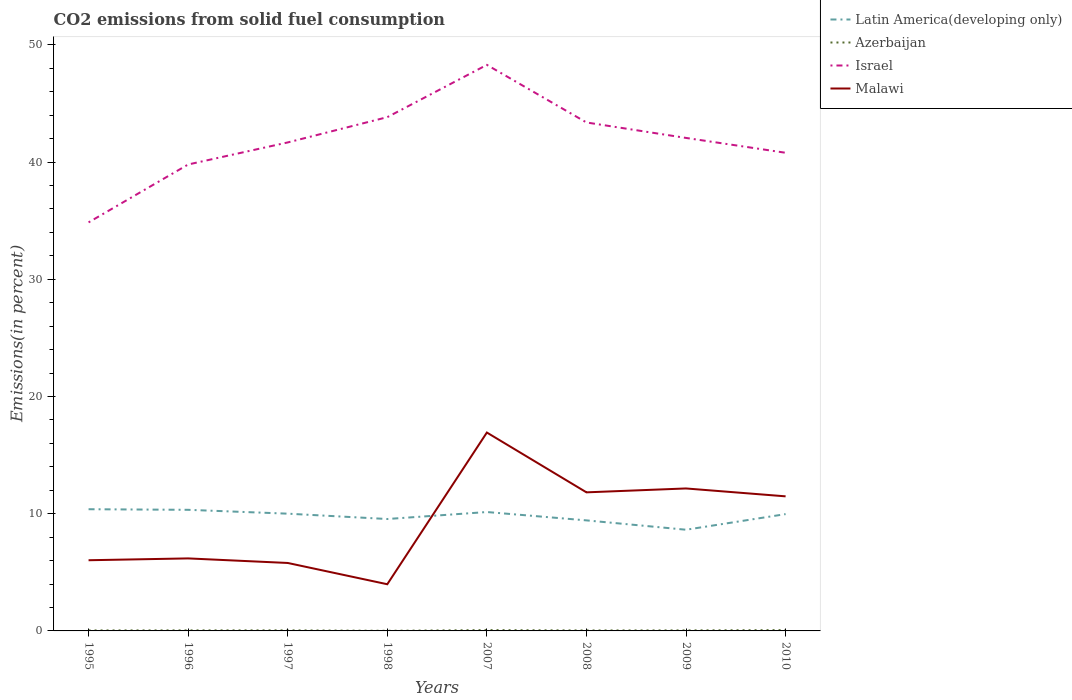Does the line corresponding to Malawi intersect with the line corresponding to Latin America(developing only)?
Your answer should be compact. Yes. Is the number of lines equal to the number of legend labels?
Provide a succinct answer. Yes. Across all years, what is the maximum total CO2 emitted in Latin America(developing only)?
Give a very brief answer. 8.63. What is the total total CO2 emitted in Azerbaijan in the graph?
Ensure brevity in your answer.  -0.03. What is the difference between the highest and the second highest total CO2 emitted in Israel?
Make the answer very short. 13.44. What is the difference between the highest and the lowest total CO2 emitted in Azerbaijan?
Provide a succinct answer. 3. Is the total CO2 emitted in Latin America(developing only) strictly greater than the total CO2 emitted in Azerbaijan over the years?
Give a very brief answer. No. How many lines are there?
Offer a very short reply. 4. Where does the legend appear in the graph?
Your answer should be compact. Top right. How are the legend labels stacked?
Ensure brevity in your answer.  Vertical. What is the title of the graph?
Give a very brief answer. CO2 emissions from solid fuel consumption. What is the label or title of the Y-axis?
Make the answer very short. Emissions(in percent). What is the Emissions(in percent) in Latin America(developing only) in 1995?
Provide a short and direct response. 10.38. What is the Emissions(in percent) of Azerbaijan in 1995?
Ensure brevity in your answer.  0.04. What is the Emissions(in percent) of Israel in 1995?
Your answer should be very brief. 34.85. What is the Emissions(in percent) in Malawi in 1995?
Ensure brevity in your answer.  6.03. What is the Emissions(in percent) of Latin America(developing only) in 1996?
Your answer should be compact. 10.33. What is the Emissions(in percent) of Azerbaijan in 1996?
Provide a succinct answer. 0.05. What is the Emissions(in percent) in Israel in 1996?
Keep it short and to the point. 39.79. What is the Emissions(in percent) of Malawi in 1996?
Ensure brevity in your answer.  6.19. What is the Emissions(in percent) in Latin America(developing only) in 1997?
Give a very brief answer. 10. What is the Emissions(in percent) of Azerbaijan in 1997?
Ensure brevity in your answer.  0.05. What is the Emissions(in percent) in Israel in 1997?
Your answer should be compact. 41.67. What is the Emissions(in percent) of Malawi in 1997?
Give a very brief answer. 5.8. What is the Emissions(in percent) of Latin America(developing only) in 1998?
Provide a short and direct response. 9.55. What is the Emissions(in percent) in Azerbaijan in 1998?
Ensure brevity in your answer.  0.01. What is the Emissions(in percent) of Israel in 1998?
Offer a very short reply. 43.83. What is the Emissions(in percent) of Malawi in 1998?
Give a very brief answer. 3.98. What is the Emissions(in percent) of Latin America(developing only) in 2007?
Your answer should be very brief. 10.14. What is the Emissions(in percent) of Azerbaijan in 2007?
Provide a short and direct response. 0.07. What is the Emissions(in percent) in Israel in 2007?
Provide a short and direct response. 48.29. What is the Emissions(in percent) in Malawi in 2007?
Provide a succinct answer. 16.92. What is the Emissions(in percent) in Latin America(developing only) in 2008?
Keep it short and to the point. 9.43. What is the Emissions(in percent) of Azerbaijan in 2008?
Provide a succinct answer. 0.04. What is the Emissions(in percent) in Israel in 2008?
Offer a very short reply. 43.37. What is the Emissions(in percent) in Malawi in 2008?
Offer a very short reply. 11.82. What is the Emissions(in percent) of Latin America(developing only) in 2009?
Make the answer very short. 8.63. What is the Emissions(in percent) of Azerbaijan in 2009?
Your answer should be compact. 0.05. What is the Emissions(in percent) of Israel in 2009?
Your answer should be very brief. 42.05. What is the Emissions(in percent) of Malawi in 2009?
Your answer should be compact. 12.15. What is the Emissions(in percent) in Latin America(developing only) in 2010?
Offer a very short reply. 9.96. What is the Emissions(in percent) in Azerbaijan in 2010?
Give a very brief answer. 0.07. What is the Emissions(in percent) in Israel in 2010?
Your answer should be compact. 40.79. What is the Emissions(in percent) in Malawi in 2010?
Offer a very short reply. 11.48. Across all years, what is the maximum Emissions(in percent) in Latin America(developing only)?
Offer a terse response. 10.38. Across all years, what is the maximum Emissions(in percent) in Azerbaijan?
Keep it short and to the point. 0.07. Across all years, what is the maximum Emissions(in percent) in Israel?
Ensure brevity in your answer.  48.29. Across all years, what is the maximum Emissions(in percent) in Malawi?
Give a very brief answer. 16.92. Across all years, what is the minimum Emissions(in percent) of Latin America(developing only)?
Provide a short and direct response. 8.63. Across all years, what is the minimum Emissions(in percent) of Azerbaijan?
Give a very brief answer. 0.01. Across all years, what is the minimum Emissions(in percent) of Israel?
Offer a very short reply. 34.85. Across all years, what is the minimum Emissions(in percent) of Malawi?
Your response must be concise. 3.98. What is the total Emissions(in percent) of Latin America(developing only) in the graph?
Make the answer very short. 78.43. What is the total Emissions(in percent) in Azerbaijan in the graph?
Provide a short and direct response. 0.38. What is the total Emissions(in percent) in Israel in the graph?
Provide a succinct answer. 334.64. What is the total Emissions(in percent) of Malawi in the graph?
Give a very brief answer. 74.37. What is the difference between the Emissions(in percent) in Latin America(developing only) in 1995 and that in 1996?
Your answer should be very brief. 0.05. What is the difference between the Emissions(in percent) of Azerbaijan in 1995 and that in 1996?
Your answer should be compact. -0. What is the difference between the Emissions(in percent) in Israel in 1995 and that in 1996?
Provide a succinct answer. -4.94. What is the difference between the Emissions(in percent) in Malawi in 1995 and that in 1996?
Your answer should be very brief. -0.16. What is the difference between the Emissions(in percent) of Latin America(developing only) in 1995 and that in 1997?
Provide a succinct answer. 0.38. What is the difference between the Emissions(in percent) in Azerbaijan in 1995 and that in 1997?
Make the answer very short. -0.01. What is the difference between the Emissions(in percent) of Israel in 1995 and that in 1997?
Your answer should be very brief. -6.82. What is the difference between the Emissions(in percent) in Malawi in 1995 and that in 1997?
Offer a very short reply. 0.23. What is the difference between the Emissions(in percent) in Latin America(developing only) in 1995 and that in 1998?
Offer a very short reply. 0.84. What is the difference between the Emissions(in percent) in Azerbaijan in 1995 and that in 1998?
Offer a terse response. 0.03. What is the difference between the Emissions(in percent) in Israel in 1995 and that in 1998?
Offer a terse response. -8.98. What is the difference between the Emissions(in percent) in Malawi in 1995 and that in 1998?
Provide a short and direct response. 2.05. What is the difference between the Emissions(in percent) in Latin America(developing only) in 1995 and that in 2007?
Your answer should be very brief. 0.24. What is the difference between the Emissions(in percent) in Azerbaijan in 1995 and that in 2007?
Offer a terse response. -0.03. What is the difference between the Emissions(in percent) in Israel in 1995 and that in 2007?
Provide a succinct answer. -13.44. What is the difference between the Emissions(in percent) of Malawi in 1995 and that in 2007?
Provide a short and direct response. -10.89. What is the difference between the Emissions(in percent) in Latin America(developing only) in 1995 and that in 2008?
Ensure brevity in your answer.  0.95. What is the difference between the Emissions(in percent) in Azerbaijan in 1995 and that in 2008?
Offer a very short reply. 0. What is the difference between the Emissions(in percent) in Israel in 1995 and that in 2008?
Your response must be concise. -8.52. What is the difference between the Emissions(in percent) of Malawi in 1995 and that in 2008?
Offer a very short reply. -5.79. What is the difference between the Emissions(in percent) in Latin America(developing only) in 1995 and that in 2009?
Give a very brief answer. 1.75. What is the difference between the Emissions(in percent) in Azerbaijan in 1995 and that in 2009?
Keep it short and to the point. -0. What is the difference between the Emissions(in percent) in Israel in 1995 and that in 2009?
Ensure brevity in your answer.  -7.2. What is the difference between the Emissions(in percent) of Malawi in 1995 and that in 2009?
Your response must be concise. -6.12. What is the difference between the Emissions(in percent) of Latin America(developing only) in 1995 and that in 2010?
Your answer should be compact. 0.42. What is the difference between the Emissions(in percent) in Azerbaijan in 1995 and that in 2010?
Ensure brevity in your answer.  -0.03. What is the difference between the Emissions(in percent) in Israel in 1995 and that in 2010?
Provide a short and direct response. -5.94. What is the difference between the Emissions(in percent) of Malawi in 1995 and that in 2010?
Keep it short and to the point. -5.45. What is the difference between the Emissions(in percent) of Latin America(developing only) in 1996 and that in 1997?
Keep it short and to the point. 0.33. What is the difference between the Emissions(in percent) of Azerbaijan in 1996 and that in 1997?
Make the answer very short. -0. What is the difference between the Emissions(in percent) of Israel in 1996 and that in 1997?
Your answer should be very brief. -1.88. What is the difference between the Emissions(in percent) in Malawi in 1996 and that in 1997?
Ensure brevity in your answer.  0.39. What is the difference between the Emissions(in percent) of Latin America(developing only) in 1996 and that in 1998?
Give a very brief answer. 0.78. What is the difference between the Emissions(in percent) of Azerbaijan in 1996 and that in 1998?
Your answer should be compact. 0.04. What is the difference between the Emissions(in percent) in Israel in 1996 and that in 1998?
Your answer should be compact. -4.04. What is the difference between the Emissions(in percent) of Malawi in 1996 and that in 1998?
Provide a short and direct response. 2.2. What is the difference between the Emissions(in percent) of Latin America(developing only) in 1996 and that in 2007?
Provide a succinct answer. 0.19. What is the difference between the Emissions(in percent) in Azerbaijan in 1996 and that in 2007?
Give a very brief answer. -0.03. What is the difference between the Emissions(in percent) of Israel in 1996 and that in 2007?
Your response must be concise. -8.5. What is the difference between the Emissions(in percent) of Malawi in 1996 and that in 2007?
Provide a short and direct response. -10.74. What is the difference between the Emissions(in percent) of Latin America(developing only) in 1996 and that in 2008?
Your answer should be very brief. 0.9. What is the difference between the Emissions(in percent) of Azerbaijan in 1996 and that in 2008?
Ensure brevity in your answer.  0.01. What is the difference between the Emissions(in percent) in Israel in 1996 and that in 2008?
Make the answer very short. -3.59. What is the difference between the Emissions(in percent) of Malawi in 1996 and that in 2008?
Give a very brief answer. -5.64. What is the difference between the Emissions(in percent) of Latin America(developing only) in 1996 and that in 2009?
Provide a succinct answer. 1.7. What is the difference between the Emissions(in percent) in Azerbaijan in 1996 and that in 2009?
Make the answer very short. 0. What is the difference between the Emissions(in percent) in Israel in 1996 and that in 2009?
Your response must be concise. -2.27. What is the difference between the Emissions(in percent) of Malawi in 1996 and that in 2009?
Your answer should be very brief. -5.97. What is the difference between the Emissions(in percent) in Latin America(developing only) in 1996 and that in 2010?
Keep it short and to the point. 0.37. What is the difference between the Emissions(in percent) of Azerbaijan in 1996 and that in 2010?
Your response must be concise. -0.03. What is the difference between the Emissions(in percent) of Israel in 1996 and that in 2010?
Keep it short and to the point. -1. What is the difference between the Emissions(in percent) of Malawi in 1996 and that in 2010?
Provide a short and direct response. -5.29. What is the difference between the Emissions(in percent) of Latin America(developing only) in 1997 and that in 1998?
Your answer should be very brief. 0.46. What is the difference between the Emissions(in percent) in Azerbaijan in 1997 and that in 1998?
Keep it short and to the point. 0.04. What is the difference between the Emissions(in percent) of Israel in 1997 and that in 1998?
Your response must be concise. -2.16. What is the difference between the Emissions(in percent) in Malawi in 1997 and that in 1998?
Your response must be concise. 1.81. What is the difference between the Emissions(in percent) of Latin America(developing only) in 1997 and that in 2007?
Give a very brief answer. -0.14. What is the difference between the Emissions(in percent) in Azerbaijan in 1997 and that in 2007?
Offer a terse response. -0.02. What is the difference between the Emissions(in percent) in Israel in 1997 and that in 2007?
Your answer should be compact. -6.62. What is the difference between the Emissions(in percent) of Malawi in 1997 and that in 2007?
Make the answer very short. -11.13. What is the difference between the Emissions(in percent) in Latin America(developing only) in 1997 and that in 2008?
Provide a succinct answer. 0.57. What is the difference between the Emissions(in percent) in Azerbaijan in 1997 and that in 2008?
Offer a terse response. 0.01. What is the difference between the Emissions(in percent) of Israel in 1997 and that in 2008?
Ensure brevity in your answer.  -1.7. What is the difference between the Emissions(in percent) of Malawi in 1997 and that in 2008?
Make the answer very short. -6.02. What is the difference between the Emissions(in percent) in Latin America(developing only) in 1997 and that in 2009?
Keep it short and to the point. 1.37. What is the difference between the Emissions(in percent) in Azerbaijan in 1997 and that in 2009?
Give a very brief answer. 0. What is the difference between the Emissions(in percent) in Israel in 1997 and that in 2009?
Ensure brevity in your answer.  -0.38. What is the difference between the Emissions(in percent) in Malawi in 1997 and that in 2009?
Make the answer very short. -6.36. What is the difference between the Emissions(in percent) in Latin America(developing only) in 1997 and that in 2010?
Provide a succinct answer. 0.04. What is the difference between the Emissions(in percent) in Azerbaijan in 1997 and that in 2010?
Provide a succinct answer. -0.02. What is the difference between the Emissions(in percent) of Israel in 1997 and that in 2010?
Ensure brevity in your answer.  0.88. What is the difference between the Emissions(in percent) in Malawi in 1997 and that in 2010?
Offer a very short reply. -5.68. What is the difference between the Emissions(in percent) in Latin America(developing only) in 1998 and that in 2007?
Offer a terse response. -0.6. What is the difference between the Emissions(in percent) of Azerbaijan in 1998 and that in 2007?
Give a very brief answer. -0.06. What is the difference between the Emissions(in percent) in Israel in 1998 and that in 2007?
Your response must be concise. -4.46. What is the difference between the Emissions(in percent) of Malawi in 1998 and that in 2007?
Offer a very short reply. -12.94. What is the difference between the Emissions(in percent) in Latin America(developing only) in 1998 and that in 2008?
Offer a very short reply. 0.12. What is the difference between the Emissions(in percent) in Azerbaijan in 1998 and that in 2008?
Offer a very short reply. -0.03. What is the difference between the Emissions(in percent) of Israel in 1998 and that in 2008?
Ensure brevity in your answer.  0.45. What is the difference between the Emissions(in percent) of Malawi in 1998 and that in 2008?
Give a very brief answer. -7.84. What is the difference between the Emissions(in percent) of Latin America(developing only) in 1998 and that in 2009?
Give a very brief answer. 0.91. What is the difference between the Emissions(in percent) of Azerbaijan in 1998 and that in 2009?
Ensure brevity in your answer.  -0.03. What is the difference between the Emissions(in percent) in Israel in 1998 and that in 2009?
Your answer should be very brief. 1.77. What is the difference between the Emissions(in percent) of Malawi in 1998 and that in 2009?
Provide a short and direct response. -8.17. What is the difference between the Emissions(in percent) of Latin America(developing only) in 1998 and that in 2010?
Your answer should be compact. -0.42. What is the difference between the Emissions(in percent) of Azerbaijan in 1998 and that in 2010?
Make the answer very short. -0.06. What is the difference between the Emissions(in percent) of Israel in 1998 and that in 2010?
Provide a short and direct response. 3.04. What is the difference between the Emissions(in percent) in Malawi in 1998 and that in 2010?
Your answer should be compact. -7.5. What is the difference between the Emissions(in percent) of Latin America(developing only) in 2007 and that in 2008?
Provide a succinct answer. 0.71. What is the difference between the Emissions(in percent) of Azerbaijan in 2007 and that in 2008?
Offer a very short reply. 0.03. What is the difference between the Emissions(in percent) of Israel in 2007 and that in 2008?
Your response must be concise. 4.91. What is the difference between the Emissions(in percent) of Malawi in 2007 and that in 2008?
Your answer should be very brief. 5.1. What is the difference between the Emissions(in percent) of Latin America(developing only) in 2007 and that in 2009?
Provide a succinct answer. 1.51. What is the difference between the Emissions(in percent) of Azerbaijan in 2007 and that in 2009?
Your response must be concise. 0.03. What is the difference between the Emissions(in percent) in Israel in 2007 and that in 2009?
Give a very brief answer. 6.23. What is the difference between the Emissions(in percent) of Malawi in 2007 and that in 2009?
Keep it short and to the point. 4.77. What is the difference between the Emissions(in percent) of Latin America(developing only) in 2007 and that in 2010?
Your answer should be compact. 0.18. What is the difference between the Emissions(in percent) of Israel in 2007 and that in 2010?
Your answer should be compact. 7.5. What is the difference between the Emissions(in percent) of Malawi in 2007 and that in 2010?
Keep it short and to the point. 5.44. What is the difference between the Emissions(in percent) in Latin America(developing only) in 2008 and that in 2009?
Keep it short and to the point. 0.8. What is the difference between the Emissions(in percent) of Azerbaijan in 2008 and that in 2009?
Your response must be concise. -0. What is the difference between the Emissions(in percent) in Israel in 2008 and that in 2009?
Keep it short and to the point. 1.32. What is the difference between the Emissions(in percent) of Malawi in 2008 and that in 2009?
Make the answer very short. -0.33. What is the difference between the Emissions(in percent) of Latin America(developing only) in 2008 and that in 2010?
Keep it short and to the point. -0.53. What is the difference between the Emissions(in percent) of Azerbaijan in 2008 and that in 2010?
Offer a terse response. -0.03. What is the difference between the Emissions(in percent) in Israel in 2008 and that in 2010?
Your answer should be very brief. 2.59. What is the difference between the Emissions(in percent) in Malawi in 2008 and that in 2010?
Make the answer very short. 0.34. What is the difference between the Emissions(in percent) in Latin America(developing only) in 2009 and that in 2010?
Ensure brevity in your answer.  -1.33. What is the difference between the Emissions(in percent) of Azerbaijan in 2009 and that in 2010?
Your answer should be very brief. -0.03. What is the difference between the Emissions(in percent) in Israel in 2009 and that in 2010?
Provide a succinct answer. 1.27. What is the difference between the Emissions(in percent) of Malawi in 2009 and that in 2010?
Offer a terse response. 0.67. What is the difference between the Emissions(in percent) in Latin America(developing only) in 1995 and the Emissions(in percent) in Azerbaijan in 1996?
Ensure brevity in your answer.  10.33. What is the difference between the Emissions(in percent) of Latin America(developing only) in 1995 and the Emissions(in percent) of Israel in 1996?
Offer a terse response. -29.41. What is the difference between the Emissions(in percent) in Latin America(developing only) in 1995 and the Emissions(in percent) in Malawi in 1996?
Offer a very short reply. 4.2. What is the difference between the Emissions(in percent) in Azerbaijan in 1995 and the Emissions(in percent) in Israel in 1996?
Provide a short and direct response. -39.74. What is the difference between the Emissions(in percent) in Azerbaijan in 1995 and the Emissions(in percent) in Malawi in 1996?
Offer a terse response. -6.14. What is the difference between the Emissions(in percent) in Israel in 1995 and the Emissions(in percent) in Malawi in 1996?
Give a very brief answer. 28.67. What is the difference between the Emissions(in percent) in Latin America(developing only) in 1995 and the Emissions(in percent) in Azerbaijan in 1997?
Your response must be concise. 10.33. What is the difference between the Emissions(in percent) in Latin America(developing only) in 1995 and the Emissions(in percent) in Israel in 1997?
Your response must be concise. -31.29. What is the difference between the Emissions(in percent) in Latin America(developing only) in 1995 and the Emissions(in percent) in Malawi in 1997?
Provide a short and direct response. 4.58. What is the difference between the Emissions(in percent) in Azerbaijan in 1995 and the Emissions(in percent) in Israel in 1997?
Your answer should be compact. -41.63. What is the difference between the Emissions(in percent) in Azerbaijan in 1995 and the Emissions(in percent) in Malawi in 1997?
Keep it short and to the point. -5.75. What is the difference between the Emissions(in percent) in Israel in 1995 and the Emissions(in percent) in Malawi in 1997?
Ensure brevity in your answer.  29.05. What is the difference between the Emissions(in percent) of Latin America(developing only) in 1995 and the Emissions(in percent) of Azerbaijan in 1998?
Keep it short and to the point. 10.37. What is the difference between the Emissions(in percent) in Latin America(developing only) in 1995 and the Emissions(in percent) in Israel in 1998?
Make the answer very short. -33.45. What is the difference between the Emissions(in percent) in Latin America(developing only) in 1995 and the Emissions(in percent) in Malawi in 1998?
Provide a succinct answer. 6.4. What is the difference between the Emissions(in percent) in Azerbaijan in 1995 and the Emissions(in percent) in Israel in 1998?
Provide a succinct answer. -43.78. What is the difference between the Emissions(in percent) in Azerbaijan in 1995 and the Emissions(in percent) in Malawi in 1998?
Make the answer very short. -3.94. What is the difference between the Emissions(in percent) of Israel in 1995 and the Emissions(in percent) of Malawi in 1998?
Provide a succinct answer. 30.87. What is the difference between the Emissions(in percent) in Latin America(developing only) in 1995 and the Emissions(in percent) in Azerbaijan in 2007?
Make the answer very short. 10.31. What is the difference between the Emissions(in percent) of Latin America(developing only) in 1995 and the Emissions(in percent) of Israel in 2007?
Make the answer very short. -37.91. What is the difference between the Emissions(in percent) in Latin America(developing only) in 1995 and the Emissions(in percent) in Malawi in 2007?
Keep it short and to the point. -6.54. What is the difference between the Emissions(in percent) in Azerbaijan in 1995 and the Emissions(in percent) in Israel in 2007?
Provide a succinct answer. -48.24. What is the difference between the Emissions(in percent) in Azerbaijan in 1995 and the Emissions(in percent) in Malawi in 2007?
Give a very brief answer. -16.88. What is the difference between the Emissions(in percent) of Israel in 1995 and the Emissions(in percent) of Malawi in 2007?
Keep it short and to the point. 17.93. What is the difference between the Emissions(in percent) of Latin America(developing only) in 1995 and the Emissions(in percent) of Azerbaijan in 2008?
Make the answer very short. 10.34. What is the difference between the Emissions(in percent) in Latin America(developing only) in 1995 and the Emissions(in percent) in Israel in 2008?
Give a very brief answer. -32.99. What is the difference between the Emissions(in percent) in Latin America(developing only) in 1995 and the Emissions(in percent) in Malawi in 2008?
Your response must be concise. -1.44. What is the difference between the Emissions(in percent) in Azerbaijan in 1995 and the Emissions(in percent) in Israel in 2008?
Offer a terse response. -43.33. What is the difference between the Emissions(in percent) in Azerbaijan in 1995 and the Emissions(in percent) in Malawi in 2008?
Ensure brevity in your answer.  -11.78. What is the difference between the Emissions(in percent) of Israel in 1995 and the Emissions(in percent) of Malawi in 2008?
Your response must be concise. 23.03. What is the difference between the Emissions(in percent) of Latin America(developing only) in 1995 and the Emissions(in percent) of Azerbaijan in 2009?
Provide a short and direct response. 10.34. What is the difference between the Emissions(in percent) in Latin America(developing only) in 1995 and the Emissions(in percent) in Israel in 2009?
Your answer should be very brief. -31.67. What is the difference between the Emissions(in percent) of Latin America(developing only) in 1995 and the Emissions(in percent) of Malawi in 2009?
Offer a very short reply. -1.77. What is the difference between the Emissions(in percent) in Azerbaijan in 1995 and the Emissions(in percent) in Israel in 2009?
Provide a short and direct response. -42.01. What is the difference between the Emissions(in percent) of Azerbaijan in 1995 and the Emissions(in percent) of Malawi in 2009?
Your answer should be very brief. -12.11. What is the difference between the Emissions(in percent) in Israel in 1995 and the Emissions(in percent) in Malawi in 2009?
Your answer should be compact. 22.7. What is the difference between the Emissions(in percent) in Latin America(developing only) in 1995 and the Emissions(in percent) in Azerbaijan in 2010?
Provide a succinct answer. 10.31. What is the difference between the Emissions(in percent) in Latin America(developing only) in 1995 and the Emissions(in percent) in Israel in 2010?
Provide a succinct answer. -30.41. What is the difference between the Emissions(in percent) in Latin America(developing only) in 1995 and the Emissions(in percent) in Malawi in 2010?
Ensure brevity in your answer.  -1.1. What is the difference between the Emissions(in percent) in Azerbaijan in 1995 and the Emissions(in percent) in Israel in 2010?
Offer a terse response. -40.74. What is the difference between the Emissions(in percent) in Azerbaijan in 1995 and the Emissions(in percent) in Malawi in 2010?
Make the answer very short. -11.44. What is the difference between the Emissions(in percent) in Israel in 1995 and the Emissions(in percent) in Malawi in 2010?
Your response must be concise. 23.37. What is the difference between the Emissions(in percent) in Latin America(developing only) in 1996 and the Emissions(in percent) in Azerbaijan in 1997?
Offer a terse response. 10.28. What is the difference between the Emissions(in percent) of Latin America(developing only) in 1996 and the Emissions(in percent) of Israel in 1997?
Make the answer very short. -31.34. What is the difference between the Emissions(in percent) of Latin America(developing only) in 1996 and the Emissions(in percent) of Malawi in 1997?
Your answer should be compact. 4.53. What is the difference between the Emissions(in percent) in Azerbaijan in 1996 and the Emissions(in percent) in Israel in 1997?
Offer a very short reply. -41.62. What is the difference between the Emissions(in percent) in Azerbaijan in 1996 and the Emissions(in percent) in Malawi in 1997?
Your answer should be compact. -5.75. What is the difference between the Emissions(in percent) in Israel in 1996 and the Emissions(in percent) in Malawi in 1997?
Your answer should be very brief. 33.99. What is the difference between the Emissions(in percent) in Latin America(developing only) in 1996 and the Emissions(in percent) in Azerbaijan in 1998?
Ensure brevity in your answer.  10.32. What is the difference between the Emissions(in percent) in Latin America(developing only) in 1996 and the Emissions(in percent) in Israel in 1998?
Give a very brief answer. -33.5. What is the difference between the Emissions(in percent) in Latin America(developing only) in 1996 and the Emissions(in percent) in Malawi in 1998?
Provide a short and direct response. 6.35. What is the difference between the Emissions(in percent) of Azerbaijan in 1996 and the Emissions(in percent) of Israel in 1998?
Offer a terse response. -43.78. What is the difference between the Emissions(in percent) in Azerbaijan in 1996 and the Emissions(in percent) in Malawi in 1998?
Offer a terse response. -3.94. What is the difference between the Emissions(in percent) in Israel in 1996 and the Emissions(in percent) in Malawi in 1998?
Give a very brief answer. 35.81. What is the difference between the Emissions(in percent) of Latin America(developing only) in 1996 and the Emissions(in percent) of Azerbaijan in 2007?
Your answer should be compact. 10.26. What is the difference between the Emissions(in percent) of Latin America(developing only) in 1996 and the Emissions(in percent) of Israel in 2007?
Your answer should be compact. -37.96. What is the difference between the Emissions(in percent) of Latin America(developing only) in 1996 and the Emissions(in percent) of Malawi in 2007?
Your answer should be compact. -6.59. What is the difference between the Emissions(in percent) of Azerbaijan in 1996 and the Emissions(in percent) of Israel in 2007?
Give a very brief answer. -48.24. What is the difference between the Emissions(in percent) of Azerbaijan in 1996 and the Emissions(in percent) of Malawi in 2007?
Offer a terse response. -16.88. What is the difference between the Emissions(in percent) in Israel in 1996 and the Emissions(in percent) in Malawi in 2007?
Make the answer very short. 22.87. What is the difference between the Emissions(in percent) of Latin America(developing only) in 1996 and the Emissions(in percent) of Azerbaijan in 2008?
Your answer should be compact. 10.29. What is the difference between the Emissions(in percent) of Latin America(developing only) in 1996 and the Emissions(in percent) of Israel in 2008?
Keep it short and to the point. -33.04. What is the difference between the Emissions(in percent) of Latin America(developing only) in 1996 and the Emissions(in percent) of Malawi in 2008?
Your answer should be very brief. -1.49. What is the difference between the Emissions(in percent) in Azerbaijan in 1996 and the Emissions(in percent) in Israel in 2008?
Make the answer very short. -43.33. What is the difference between the Emissions(in percent) of Azerbaijan in 1996 and the Emissions(in percent) of Malawi in 2008?
Provide a short and direct response. -11.77. What is the difference between the Emissions(in percent) in Israel in 1996 and the Emissions(in percent) in Malawi in 2008?
Provide a succinct answer. 27.97. What is the difference between the Emissions(in percent) of Latin America(developing only) in 1996 and the Emissions(in percent) of Azerbaijan in 2009?
Your response must be concise. 10.29. What is the difference between the Emissions(in percent) of Latin America(developing only) in 1996 and the Emissions(in percent) of Israel in 2009?
Offer a terse response. -31.72. What is the difference between the Emissions(in percent) in Latin America(developing only) in 1996 and the Emissions(in percent) in Malawi in 2009?
Ensure brevity in your answer.  -1.82. What is the difference between the Emissions(in percent) in Azerbaijan in 1996 and the Emissions(in percent) in Israel in 2009?
Provide a succinct answer. -42.01. What is the difference between the Emissions(in percent) in Azerbaijan in 1996 and the Emissions(in percent) in Malawi in 2009?
Your answer should be very brief. -12.11. What is the difference between the Emissions(in percent) of Israel in 1996 and the Emissions(in percent) of Malawi in 2009?
Make the answer very short. 27.64. What is the difference between the Emissions(in percent) of Latin America(developing only) in 1996 and the Emissions(in percent) of Azerbaijan in 2010?
Offer a terse response. 10.26. What is the difference between the Emissions(in percent) of Latin America(developing only) in 1996 and the Emissions(in percent) of Israel in 2010?
Provide a succinct answer. -30.46. What is the difference between the Emissions(in percent) in Latin America(developing only) in 1996 and the Emissions(in percent) in Malawi in 2010?
Provide a short and direct response. -1.15. What is the difference between the Emissions(in percent) in Azerbaijan in 1996 and the Emissions(in percent) in Israel in 2010?
Keep it short and to the point. -40.74. What is the difference between the Emissions(in percent) of Azerbaijan in 1996 and the Emissions(in percent) of Malawi in 2010?
Your answer should be very brief. -11.43. What is the difference between the Emissions(in percent) in Israel in 1996 and the Emissions(in percent) in Malawi in 2010?
Ensure brevity in your answer.  28.31. What is the difference between the Emissions(in percent) of Latin America(developing only) in 1997 and the Emissions(in percent) of Azerbaijan in 1998?
Your answer should be compact. 9.99. What is the difference between the Emissions(in percent) of Latin America(developing only) in 1997 and the Emissions(in percent) of Israel in 1998?
Offer a terse response. -33.82. What is the difference between the Emissions(in percent) in Latin America(developing only) in 1997 and the Emissions(in percent) in Malawi in 1998?
Provide a short and direct response. 6.02. What is the difference between the Emissions(in percent) in Azerbaijan in 1997 and the Emissions(in percent) in Israel in 1998?
Offer a very short reply. -43.78. What is the difference between the Emissions(in percent) of Azerbaijan in 1997 and the Emissions(in percent) of Malawi in 1998?
Make the answer very short. -3.93. What is the difference between the Emissions(in percent) in Israel in 1997 and the Emissions(in percent) in Malawi in 1998?
Your answer should be very brief. 37.69. What is the difference between the Emissions(in percent) in Latin America(developing only) in 1997 and the Emissions(in percent) in Azerbaijan in 2007?
Provide a short and direct response. 9.93. What is the difference between the Emissions(in percent) of Latin America(developing only) in 1997 and the Emissions(in percent) of Israel in 2007?
Ensure brevity in your answer.  -38.28. What is the difference between the Emissions(in percent) of Latin America(developing only) in 1997 and the Emissions(in percent) of Malawi in 2007?
Provide a short and direct response. -6.92. What is the difference between the Emissions(in percent) in Azerbaijan in 1997 and the Emissions(in percent) in Israel in 2007?
Your answer should be compact. -48.24. What is the difference between the Emissions(in percent) in Azerbaijan in 1997 and the Emissions(in percent) in Malawi in 2007?
Keep it short and to the point. -16.87. What is the difference between the Emissions(in percent) of Israel in 1997 and the Emissions(in percent) of Malawi in 2007?
Offer a very short reply. 24.75. What is the difference between the Emissions(in percent) in Latin America(developing only) in 1997 and the Emissions(in percent) in Azerbaijan in 2008?
Keep it short and to the point. 9.96. What is the difference between the Emissions(in percent) in Latin America(developing only) in 1997 and the Emissions(in percent) in Israel in 2008?
Your response must be concise. -33.37. What is the difference between the Emissions(in percent) in Latin America(developing only) in 1997 and the Emissions(in percent) in Malawi in 2008?
Offer a terse response. -1.82. What is the difference between the Emissions(in percent) of Azerbaijan in 1997 and the Emissions(in percent) of Israel in 2008?
Your response must be concise. -43.33. What is the difference between the Emissions(in percent) of Azerbaijan in 1997 and the Emissions(in percent) of Malawi in 2008?
Your response must be concise. -11.77. What is the difference between the Emissions(in percent) of Israel in 1997 and the Emissions(in percent) of Malawi in 2008?
Offer a very short reply. 29.85. What is the difference between the Emissions(in percent) of Latin America(developing only) in 1997 and the Emissions(in percent) of Azerbaijan in 2009?
Your answer should be compact. 9.96. What is the difference between the Emissions(in percent) in Latin America(developing only) in 1997 and the Emissions(in percent) in Israel in 2009?
Your response must be concise. -32.05. What is the difference between the Emissions(in percent) in Latin America(developing only) in 1997 and the Emissions(in percent) in Malawi in 2009?
Make the answer very short. -2.15. What is the difference between the Emissions(in percent) in Azerbaijan in 1997 and the Emissions(in percent) in Israel in 2009?
Offer a very short reply. -42.01. What is the difference between the Emissions(in percent) of Azerbaijan in 1997 and the Emissions(in percent) of Malawi in 2009?
Make the answer very short. -12.1. What is the difference between the Emissions(in percent) in Israel in 1997 and the Emissions(in percent) in Malawi in 2009?
Make the answer very short. 29.52. What is the difference between the Emissions(in percent) of Latin America(developing only) in 1997 and the Emissions(in percent) of Azerbaijan in 2010?
Offer a very short reply. 9.93. What is the difference between the Emissions(in percent) of Latin America(developing only) in 1997 and the Emissions(in percent) of Israel in 2010?
Ensure brevity in your answer.  -30.79. What is the difference between the Emissions(in percent) in Latin America(developing only) in 1997 and the Emissions(in percent) in Malawi in 2010?
Your answer should be very brief. -1.48. What is the difference between the Emissions(in percent) in Azerbaijan in 1997 and the Emissions(in percent) in Israel in 2010?
Your answer should be compact. -40.74. What is the difference between the Emissions(in percent) of Azerbaijan in 1997 and the Emissions(in percent) of Malawi in 2010?
Provide a succinct answer. -11.43. What is the difference between the Emissions(in percent) in Israel in 1997 and the Emissions(in percent) in Malawi in 2010?
Offer a very short reply. 30.19. What is the difference between the Emissions(in percent) of Latin America(developing only) in 1998 and the Emissions(in percent) of Azerbaijan in 2007?
Provide a short and direct response. 9.47. What is the difference between the Emissions(in percent) in Latin America(developing only) in 1998 and the Emissions(in percent) in Israel in 2007?
Offer a terse response. -38.74. What is the difference between the Emissions(in percent) of Latin America(developing only) in 1998 and the Emissions(in percent) of Malawi in 2007?
Give a very brief answer. -7.38. What is the difference between the Emissions(in percent) in Azerbaijan in 1998 and the Emissions(in percent) in Israel in 2007?
Provide a succinct answer. -48.28. What is the difference between the Emissions(in percent) in Azerbaijan in 1998 and the Emissions(in percent) in Malawi in 2007?
Make the answer very short. -16.91. What is the difference between the Emissions(in percent) in Israel in 1998 and the Emissions(in percent) in Malawi in 2007?
Your response must be concise. 26.9. What is the difference between the Emissions(in percent) of Latin America(developing only) in 1998 and the Emissions(in percent) of Azerbaijan in 2008?
Offer a terse response. 9.51. What is the difference between the Emissions(in percent) of Latin America(developing only) in 1998 and the Emissions(in percent) of Israel in 2008?
Your answer should be compact. -33.83. What is the difference between the Emissions(in percent) of Latin America(developing only) in 1998 and the Emissions(in percent) of Malawi in 2008?
Provide a short and direct response. -2.27. What is the difference between the Emissions(in percent) of Azerbaijan in 1998 and the Emissions(in percent) of Israel in 2008?
Provide a short and direct response. -43.36. What is the difference between the Emissions(in percent) in Azerbaijan in 1998 and the Emissions(in percent) in Malawi in 2008?
Your answer should be very brief. -11.81. What is the difference between the Emissions(in percent) in Israel in 1998 and the Emissions(in percent) in Malawi in 2008?
Provide a succinct answer. 32.01. What is the difference between the Emissions(in percent) of Latin America(developing only) in 1998 and the Emissions(in percent) of Azerbaijan in 2009?
Provide a short and direct response. 9.5. What is the difference between the Emissions(in percent) of Latin America(developing only) in 1998 and the Emissions(in percent) of Israel in 2009?
Give a very brief answer. -32.51. What is the difference between the Emissions(in percent) of Latin America(developing only) in 1998 and the Emissions(in percent) of Malawi in 2009?
Offer a terse response. -2.61. What is the difference between the Emissions(in percent) of Azerbaijan in 1998 and the Emissions(in percent) of Israel in 2009?
Your answer should be compact. -42.04. What is the difference between the Emissions(in percent) of Azerbaijan in 1998 and the Emissions(in percent) of Malawi in 2009?
Ensure brevity in your answer.  -12.14. What is the difference between the Emissions(in percent) of Israel in 1998 and the Emissions(in percent) of Malawi in 2009?
Provide a succinct answer. 31.67. What is the difference between the Emissions(in percent) in Latin America(developing only) in 1998 and the Emissions(in percent) in Azerbaijan in 2010?
Offer a terse response. 9.47. What is the difference between the Emissions(in percent) in Latin America(developing only) in 1998 and the Emissions(in percent) in Israel in 2010?
Your response must be concise. -31.24. What is the difference between the Emissions(in percent) in Latin America(developing only) in 1998 and the Emissions(in percent) in Malawi in 2010?
Your response must be concise. -1.93. What is the difference between the Emissions(in percent) of Azerbaijan in 1998 and the Emissions(in percent) of Israel in 2010?
Your response must be concise. -40.78. What is the difference between the Emissions(in percent) of Azerbaijan in 1998 and the Emissions(in percent) of Malawi in 2010?
Make the answer very short. -11.47. What is the difference between the Emissions(in percent) of Israel in 1998 and the Emissions(in percent) of Malawi in 2010?
Ensure brevity in your answer.  32.35. What is the difference between the Emissions(in percent) in Latin America(developing only) in 2007 and the Emissions(in percent) in Azerbaijan in 2008?
Your response must be concise. 10.1. What is the difference between the Emissions(in percent) in Latin America(developing only) in 2007 and the Emissions(in percent) in Israel in 2008?
Your answer should be very brief. -33.23. What is the difference between the Emissions(in percent) of Latin America(developing only) in 2007 and the Emissions(in percent) of Malawi in 2008?
Ensure brevity in your answer.  -1.68. What is the difference between the Emissions(in percent) of Azerbaijan in 2007 and the Emissions(in percent) of Israel in 2008?
Provide a succinct answer. -43.3. What is the difference between the Emissions(in percent) in Azerbaijan in 2007 and the Emissions(in percent) in Malawi in 2008?
Your answer should be very brief. -11.75. What is the difference between the Emissions(in percent) in Israel in 2007 and the Emissions(in percent) in Malawi in 2008?
Offer a very short reply. 36.47. What is the difference between the Emissions(in percent) of Latin America(developing only) in 2007 and the Emissions(in percent) of Azerbaijan in 2009?
Give a very brief answer. 10.1. What is the difference between the Emissions(in percent) of Latin America(developing only) in 2007 and the Emissions(in percent) of Israel in 2009?
Give a very brief answer. -31.91. What is the difference between the Emissions(in percent) of Latin America(developing only) in 2007 and the Emissions(in percent) of Malawi in 2009?
Provide a succinct answer. -2.01. What is the difference between the Emissions(in percent) of Azerbaijan in 2007 and the Emissions(in percent) of Israel in 2009?
Your answer should be very brief. -41.98. What is the difference between the Emissions(in percent) in Azerbaijan in 2007 and the Emissions(in percent) in Malawi in 2009?
Make the answer very short. -12.08. What is the difference between the Emissions(in percent) in Israel in 2007 and the Emissions(in percent) in Malawi in 2009?
Your response must be concise. 36.13. What is the difference between the Emissions(in percent) in Latin America(developing only) in 2007 and the Emissions(in percent) in Azerbaijan in 2010?
Your answer should be very brief. 10.07. What is the difference between the Emissions(in percent) in Latin America(developing only) in 2007 and the Emissions(in percent) in Israel in 2010?
Keep it short and to the point. -30.65. What is the difference between the Emissions(in percent) of Latin America(developing only) in 2007 and the Emissions(in percent) of Malawi in 2010?
Keep it short and to the point. -1.34. What is the difference between the Emissions(in percent) of Azerbaijan in 2007 and the Emissions(in percent) of Israel in 2010?
Your answer should be very brief. -40.72. What is the difference between the Emissions(in percent) in Azerbaijan in 2007 and the Emissions(in percent) in Malawi in 2010?
Ensure brevity in your answer.  -11.41. What is the difference between the Emissions(in percent) in Israel in 2007 and the Emissions(in percent) in Malawi in 2010?
Provide a short and direct response. 36.81. What is the difference between the Emissions(in percent) of Latin America(developing only) in 2008 and the Emissions(in percent) of Azerbaijan in 2009?
Provide a short and direct response. 9.38. What is the difference between the Emissions(in percent) of Latin America(developing only) in 2008 and the Emissions(in percent) of Israel in 2009?
Your answer should be very brief. -32.62. What is the difference between the Emissions(in percent) of Latin America(developing only) in 2008 and the Emissions(in percent) of Malawi in 2009?
Ensure brevity in your answer.  -2.72. What is the difference between the Emissions(in percent) of Azerbaijan in 2008 and the Emissions(in percent) of Israel in 2009?
Provide a succinct answer. -42.01. What is the difference between the Emissions(in percent) of Azerbaijan in 2008 and the Emissions(in percent) of Malawi in 2009?
Your answer should be very brief. -12.11. What is the difference between the Emissions(in percent) in Israel in 2008 and the Emissions(in percent) in Malawi in 2009?
Make the answer very short. 31.22. What is the difference between the Emissions(in percent) in Latin America(developing only) in 2008 and the Emissions(in percent) in Azerbaijan in 2010?
Provide a succinct answer. 9.36. What is the difference between the Emissions(in percent) of Latin America(developing only) in 2008 and the Emissions(in percent) of Israel in 2010?
Give a very brief answer. -31.36. What is the difference between the Emissions(in percent) in Latin America(developing only) in 2008 and the Emissions(in percent) in Malawi in 2010?
Your response must be concise. -2.05. What is the difference between the Emissions(in percent) of Azerbaijan in 2008 and the Emissions(in percent) of Israel in 2010?
Ensure brevity in your answer.  -40.75. What is the difference between the Emissions(in percent) of Azerbaijan in 2008 and the Emissions(in percent) of Malawi in 2010?
Keep it short and to the point. -11.44. What is the difference between the Emissions(in percent) of Israel in 2008 and the Emissions(in percent) of Malawi in 2010?
Ensure brevity in your answer.  31.89. What is the difference between the Emissions(in percent) of Latin America(developing only) in 2009 and the Emissions(in percent) of Azerbaijan in 2010?
Offer a terse response. 8.56. What is the difference between the Emissions(in percent) of Latin America(developing only) in 2009 and the Emissions(in percent) of Israel in 2010?
Give a very brief answer. -32.16. What is the difference between the Emissions(in percent) in Latin America(developing only) in 2009 and the Emissions(in percent) in Malawi in 2010?
Your answer should be compact. -2.85. What is the difference between the Emissions(in percent) of Azerbaijan in 2009 and the Emissions(in percent) of Israel in 2010?
Ensure brevity in your answer.  -40.74. What is the difference between the Emissions(in percent) of Azerbaijan in 2009 and the Emissions(in percent) of Malawi in 2010?
Offer a terse response. -11.43. What is the difference between the Emissions(in percent) of Israel in 2009 and the Emissions(in percent) of Malawi in 2010?
Keep it short and to the point. 30.57. What is the average Emissions(in percent) in Latin America(developing only) per year?
Offer a very short reply. 9.8. What is the average Emissions(in percent) of Azerbaijan per year?
Provide a succinct answer. 0.05. What is the average Emissions(in percent) in Israel per year?
Make the answer very short. 41.83. What is the average Emissions(in percent) of Malawi per year?
Your response must be concise. 9.3. In the year 1995, what is the difference between the Emissions(in percent) in Latin America(developing only) and Emissions(in percent) in Azerbaijan?
Ensure brevity in your answer.  10.34. In the year 1995, what is the difference between the Emissions(in percent) in Latin America(developing only) and Emissions(in percent) in Israel?
Offer a terse response. -24.47. In the year 1995, what is the difference between the Emissions(in percent) in Latin America(developing only) and Emissions(in percent) in Malawi?
Your answer should be compact. 4.35. In the year 1995, what is the difference between the Emissions(in percent) in Azerbaijan and Emissions(in percent) in Israel?
Ensure brevity in your answer.  -34.81. In the year 1995, what is the difference between the Emissions(in percent) in Azerbaijan and Emissions(in percent) in Malawi?
Provide a succinct answer. -5.99. In the year 1995, what is the difference between the Emissions(in percent) in Israel and Emissions(in percent) in Malawi?
Your answer should be compact. 28.82. In the year 1996, what is the difference between the Emissions(in percent) in Latin America(developing only) and Emissions(in percent) in Azerbaijan?
Offer a terse response. 10.28. In the year 1996, what is the difference between the Emissions(in percent) in Latin America(developing only) and Emissions(in percent) in Israel?
Keep it short and to the point. -29.46. In the year 1996, what is the difference between the Emissions(in percent) of Latin America(developing only) and Emissions(in percent) of Malawi?
Keep it short and to the point. 4.15. In the year 1996, what is the difference between the Emissions(in percent) in Azerbaijan and Emissions(in percent) in Israel?
Keep it short and to the point. -39.74. In the year 1996, what is the difference between the Emissions(in percent) in Azerbaijan and Emissions(in percent) in Malawi?
Give a very brief answer. -6.14. In the year 1996, what is the difference between the Emissions(in percent) of Israel and Emissions(in percent) of Malawi?
Provide a short and direct response. 33.6. In the year 1997, what is the difference between the Emissions(in percent) in Latin America(developing only) and Emissions(in percent) in Azerbaijan?
Offer a very short reply. 9.95. In the year 1997, what is the difference between the Emissions(in percent) of Latin America(developing only) and Emissions(in percent) of Israel?
Your answer should be very brief. -31.67. In the year 1997, what is the difference between the Emissions(in percent) in Latin America(developing only) and Emissions(in percent) in Malawi?
Ensure brevity in your answer.  4.21. In the year 1997, what is the difference between the Emissions(in percent) of Azerbaijan and Emissions(in percent) of Israel?
Give a very brief answer. -41.62. In the year 1997, what is the difference between the Emissions(in percent) in Azerbaijan and Emissions(in percent) in Malawi?
Your answer should be compact. -5.75. In the year 1997, what is the difference between the Emissions(in percent) of Israel and Emissions(in percent) of Malawi?
Your answer should be compact. 35.87. In the year 1998, what is the difference between the Emissions(in percent) of Latin America(developing only) and Emissions(in percent) of Azerbaijan?
Keep it short and to the point. 9.53. In the year 1998, what is the difference between the Emissions(in percent) of Latin America(developing only) and Emissions(in percent) of Israel?
Your response must be concise. -34.28. In the year 1998, what is the difference between the Emissions(in percent) of Latin America(developing only) and Emissions(in percent) of Malawi?
Ensure brevity in your answer.  5.56. In the year 1998, what is the difference between the Emissions(in percent) in Azerbaijan and Emissions(in percent) in Israel?
Provide a succinct answer. -43.82. In the year 1998, what is the difference between the Emissions(in percent) of Azerbaijan and Emissions(in percent) of Malawi?
Give a very brief answer. -3.97. In the year 1998, what is the difference between the Emissions(in percent) in Israel and Emissions(in percent) in Malawi?
Your answer should be compact. 39.84. In the year 2007, what is the difference between the Emissions(in percent) in Latin America(developing only) and Emissions(in percent) in Azerbaijan?
Ensure brevity in your answer.  10.07. In the year 2007, what is the difference between the Emissions(in percent) in Latin America(developing only) and Emissions(in percent) in Israel?
Your answer should be very brief. -38.14. In the year 2007, what is the difference between the Emissions(in percent) of Latin America(developing only) and Emissions(in percent) of Malawi?
Provide a short and direct response. -6.78. In the year 2007, what is the difference between the Emissions(in percent) of Azerbaijan and Emissions(in percent) of Israel?
Provide a short and direct response. -48.21. In the year 2007, what is the difference between the Emissions(in percent) of Azerbaijan and Emissions(in percent) of Malawi?
Offer a terse response. -16.85. In the year 2007, what is the difference between the Emissions(in percent) of Israel and Emissions(in percent) of Malawi?
Your answer should be very brief. 31.36. In the year 2008, what is the difference between the Emissions(in percent) of Latin America(developing only) and Emissions(in percent) of Azerbaijan?
Your answer should be very brief. 9.39. In the year 2008, what is the difference between the Emissions(in percent) of Latin America(developing only) and Emissions(in percent) of Israel?
Your answer should be very brief. -33.94. In the year 2008, what is the difference between the Emissions(in percent) in Latin America(developing only) and Emissions(in percent) in Malawi?
Provide a short and direct response. -2.39. In the year 2008, what is the difference between the Emissions(in percent) in Azerbaijan and Emissions(in percent) in Israel?
Give a very brief answer. -43.33. In the year 2008, what is the difference between the Emissions(in percent) in Azerbaijan and Emissions(in percent) in Malawi?
Your answer should be very brief. -11.78. In the year 2008, what is the difference between the Emissions(in percent) of Israel and Emissions(in percent) of Malawi?
Provide a short and direct response. 31.55. In the year 2009, what is the difference between the Emissions(in percent) in Latin America(developing only) and Emissions(in percent) in Azerbaijan?
Your answer should be very brief. 8.59. In the year 2009, what is the difference between the Emissions(in percent) in Latin America(developing only) and Emissions(in percent) in Israel?
Your response must be concise. -33.42. In the year 2009, what is the difference between the Emissions(in percent) in Latin America(developing only) and Emissions(in percent) in Malawi?
Your answer should be very brief. -3.52. In the year 2009, what is the difference between the Emissions(in percent) of Azerbaijan and Emissions(in percent) of Israel?
Give a very brief answer. -42.01. In the year 2009, what is the difference between the Emissions(in percent) of Azerbaijan and Emissions(in percent) of Malawi?
Your response must be concise. -12.11. In the year 2009, what is the difference between the Emissions(in percent) in Israel and Emissions(in percent) in Malawi?
Make the answer very short. 29.9. In the year 2010, what is the difference between the Emissions(in percent) in Latin America(developing only) and Emissions(in percent) in Azerbaijan?
Make the answer very short. 9.89. In the year 2010, what is the difference between the Emissions(in percent) in Latin America(developing only) and Emissions(in percent) in Israel?
Your answer should be very brief. -30.82. In the year 2010, what is the difference between the Emissions(in percent) in Latin America(developing only) and Emissions(in percent) in Malawi?
Your response must be concise. -1.52. In the year 2010, what is the difference between the Emissions(in percent) of Azerbaijan and Emissions(in percent) of Israel?
Provide a succinct answer. -40.72. In the year 2010, what is the difference between the Emissions(in percent) of Azerbaijan and Emissions(in percent) of Malawi?
Give a very brief answer. -11.41. In the year 2010, what is the difference between the Emissions(in percent) of Israel and Emissions(in percent) of Malawi?
Your answer should be compact. 29.31. What is the ratio of the Emissions(in percent) in Latin America(developing only) in 1995 to that in 1996?
Keep it short and to the point. 1. What is the ratio of the Emissions(in percent) of Azerbaijan in 1995 to that in 1996?
Your answer should be compact. 0.94. What is the ratio of the Emissions(in percent) in Israel in 1995 to that in 1996?
Provide a short and direct response. 0.88. What is the ratio of the Emissions(in percent) of Malawi in 1995 to that in 1996?
Offer a very short reply. 0.97. What is the ratio of the Emissions(in percent) of Latin America(developing only) in 1995 to that in 1997?
Offer a terse response. 1.04. What is the ratio of the Emissions(in percent) in Azerbaijan in 1995 to that in 1997?
Ensure brevity in your answer.  0.89. What is the ratio of the Emissions(in percent) of Israel in 1995 to that in 1997?
Make the answer very short. 0.84. What is the ratio of the Emissions(in percent) in Malawi in 1995 to that in 1997?
Your answer should be compact. 1.04. What is the ratio of the Emissions(in percent) of Latin America(developing only) in 1995 to that in 1998?
Your answer should be compact. 1.09. What is the ratio of the Emissions(in percent) in Azerbaijan in 1995 to that in 1998?
Make the answer very short. 3.78. What is the ratio of the Emissions(in percent) in Israel in 1995 to that in 1998?
Your answer should be very brief. 0.8. What is the ratio of the Emissions(in percent) of Malawi in 1995 to that in 1998?
Offer a very short reply. 1.51. What is the ratio of the Emissions(in percent) of Latin America(developing only) in 1995 to that in 2007?
Provide a short and direct response. 1.02. What is the ratio of the Emissions(in percent) of Azerbaijan in 1995 to that in 2007?
Make the answer very short. 0.61. What is the ratio of the Emissions(in percent) of Israel in 1995 to that in 2007?
Your answer should be compact. 0.72. What is the ratio of the Emissions(in percent) of Malawi in 1995 to that in 2007?
Make the answer very short. 0.36. What is the ratio of the Emissions(in percent) in Latin America(developing only) in 1995 to that in 2008?
Make the answer very short. 1.1. What is the ratio of the Emissions(in percent) of Azerbaijan in 1995 to that in 2008?
Make the answer very short. 1.06. What is the ratio of the Emissions(in percent) in Israel in 1995 to that in 2008?
Provide a short and direct response. 0.8. What is the ratio of the Emissions(in percent) in Malawi in 1995 to that in 2008?
Provide a succinct answer. 0.51. What is the ratio of the Emissions(in percent) in Latin America(developing only) in 1995 to that in 2009?
Offer a terse response. 1.2. What is the ratio of the Emissions(in percent) in Azerbaijan in 1995 to that in 2009?
Provide a succinct answer. 0.95. What is the ratio of the Emissions(in percent) of Israel in 1995 to that in 2009?
Keep it short and to the point. 0.83. What is the ratio of the Emissions(in percent) in Malawi in 1995 to that in 2009?
Keep it short and to the point. 0.5. What is the ratio of the Emissions(in percent) in Latin America(developing only) in 1995 to that in 2010?
Provide a short and direct response. 1.04. What is the ratio of the Emissions(in percent) of Azerbaijan in 1995 to that in 2010?
Your answer should be compact. 0.61. What is the ratio of the Emissions(in percent) in Israel in 1995 to that in 2010?
Ensure brevity in your answer.  0.85. What is the ratio of the Emissions(in percent) of Malawi in 1995 to that in 2010?
Give a very brief answer. 0.53. What is the ratio of the Emissions(in percent) of Latin America(developing only) in 1996 to that in 1997?
Offer a very short reply. 1.03. What is the ratio of the Emissions(in percent) in Azerbaijan in 1996 to that in 1997?
Provide a succinct answer. 0.95. What is the ratio of the Emissions(in percent) of Israel in 1996 to that in 1997?
Ensure brevity in your answer.  0.95. What is the ratio of the Emissions(in percent) of Malawi in 1996 to that in 1997?
Provide a short and direct response. 1.07. What is the ratio of the Emissions(in percent) of Latin America(developing only) in 1996 to that in 1998?
Your answer should be very brief. 1.08. What is the ratio of the Emissions(in percent) in Azerbaijan in 1996 to that in 1998?
Make the answer very short. 4.02. What is the ratio of the Emissions(in percent) of Israel in 1996 to that in 1998?
Provide a succinct answer. 0.91. What is the ratio of the Emissions(in percent) in Malawi in 1996 to that in 1998?
Your answer should be compact. 1.55. What is the ratio of the Emissions(in percent) in Latin America(developing only) in 1996 to that in 2007?
Give a very brief answer. 1.02. What is the ratio of the Emissions(in percent) in Azerbaijan in 1996 to that in 2007?
Make the answer very short. 0.65. What is the ratio of the Emissions(in percent) of Israel in 1996 to that in 2007?
Make the answer very short. 0.82. What is the ratio of the Emissions(in percent) in Malawi in 1996 to that in 2007?
Your answer should be compact. 0.37. What is the ratio of the Emissions(in percent) of Latin America(developing only) in 1996 to that in 2008?
Give a very brief answer. 1.1. What is the ratio of the Emissions(in percent) of Azerbaijan in 1996 to that in 2008?
Your answer should be very brief. 1.13. What is the ratio of the Emissions(in percent) of Israel in 1996 to that in 2008?
Your answer should be compact. 0.92. What is the ratio of the Emissions(in percent) of Malawi in 1996 to that in 2008?
Your response must be concise. 0.52. What is the ratio of the Emissions(in percent) of Latin America(developing only) in 1996 to that in 2009?
Provide a short and direct response. 1.2. What is the ratio of the Emissions(in percent) of Azerbaijan in 1996 to that in 2009?
Offer a terse response. 1.01. What is the ratio of the Emissions(in percent) in Israel in 1996 to that in 2009?
Your answer should be very brief. 0.95. What is the ratio of the Emissions(in percent) of Malawi in 1996 to that in 2009?
Your response must be concise. 0.51. What is the ratio of the Emissions(in percent) in Latin America(developing only) in 1996 to that in 2010?
Your answer should be very brief. 1.04. What is the ratio of the Emissions(in percent) of Azerbaijan in 1996 to that in 2010?
Provide a succinct answer. 0.65. What is the ratio of the Emissions(in percent) of Israel in 1996 to that in 2010?
Keep it short and to the point. 0.98. What is the ratio of the Emissions(in percent) in Malawi in 1996 to that in 2010?
Offer a terse response. 0.54. What is the ratio of the Emissions(in percent) in Latin America(developing only) in 1997 to that in 1998?
Your answer should be very brief. 1.05. What is the ratio of the Emissions(in percent) of Azerbaijan in 1997 to that in 1998?
Offer a very short reply. 4.25. What is the ratio of the Emissions(in percent) of Israel in 1997 to that in 1998?
Keep it short and to the point. 0.95. What is the ratio of the Emissions(in percent) in Malawi in 1997 to that in 1998?
Offer a very short reply. 1.46. What is the ratio of the Emissions(in percent) of Latin America(developing only) in 1997 to that in 2007?
Offer a very short reply. 0.99. What is the ratio of the Emissions(in percent) in Azerbaijan in 1997 to that in 2007?
Your response must be concise. 0.68. What is the ratio of the Emissions(in percent) of Israel in 1997 to that in 2007?
Your answer should be compact. 0.86. What is the ratio of the Emissions(in percent) of Malawi in 1997 to that in 2007?
Give a very brief answer. 0.34. What is the ratio of the Emissions(in percent) of Latin America(developing only) in 1997 to that in 2008?
Your response must be concise. 1.06. What is the ratio of the Emissions(in percent) of Azerbaijan in 1997 to that in 2008?
Keep it short and to the point. 1.19. What is the ratio of the Emissions(in percent) in Israel in 1997 to that in 2008?
Make the answer very short. 0.96. What is the ratio of the Emissions(in percent) in Malawi in 1997 to that in 2008?
Give a very brief answer. 0.49. What is the ratio of the Emissions(in percent) of Latin America(developing only) in 1997 to that in 2009?
Your answer should be compact. 1.16. What is the ratio of the Emissions(in percent) of Azerbaijan in 1997 to that in 2009?
Provide a succinct answer. 1.07. What is the ratio of the Emissions(in percent) in Israel in 1997 to that in 2009?
Keep it short and to the point. 0.99. What is the ratio of the Emissions(in percent) in Malawi in 1997 to that in 2009?
Keep it short and to the point. 0.48. What is the ratio of the Emissions(in percent) in Azerbaijan in 1997 to that in 2010?
Ensure brevity in your answer.  0.69. What is the ratio of the Emissions(in percent) of Israel in 1997 to that in 2010?
Your answer should be very brief. 1.02. What is the ratio of the Emissions(in percent) in Malawi in 1997 to that in 2010?
Your answer should be compact. 0.51. What is the ratio of the Emissions(in percent) in Azerbaijan in 1998 to that in 2007?
Your response must be concise. 0.16. What is the ratio of the Emissions(in percent) of Israel in 1998 to that in 2007?
Keep it short and to the point. 0.91. What is the ratio of the Emissions(in percent) in Malawi in 1998 to that in 2007?
Give a very brief answer. 0.24. What is the ratio of the Emissions(in percent) in Latin America(developing only) in 1998 to that in 2008?
Keep it short and to the point. 1.01. What is the ratio of the Emissions(in percent) in Azerbaijan in 1998 to that in 2008?
Offer a terse response. 0.28. What is the ratio of the Emissions(in percent) in Israel in 1998 to that in 2008?
Offer a very short reply. 1.01. What is the ratio of the Emissions(in percent) of Malawi in 1998 to that in 2008?
Your answer should be compact. 0.34. What is the ratio of the Emissions(in percent) in Latin America(developing only) in 1998 to that in 2009?
Ensure brevity in your answer.  1.11. What is the ratio of the Emissions(in percent) of Azerbaijan in 1998 to that in 2009?
Offer a very short reply. 0.25. What is the ratio of the Emissions(in percent) in Israel in 1998 to that in 2009?
Your answer should be very brief. 1.04. What is the ratio of the Emissions(in percent) of Malawi in 1998 to that in 2009?
Offer a terse response. 0.33. What is the ratio of the Emissions(in percent) of Latin America(developing only) in 1998 to that in 2010?
Ensure brevity in your answer.  0.96. What is the ratio of the Emissions(in percent) of Azerbaijan in 1998 to that in 2010?
Make the answer very short. 0.16. What is the ratio of the Emissions(in percent) in Israel in 1998 to that in 2010?
Ensure brevity in your answer.  1.07. What is the ratio of the Emissions(in percent) of Malawi in 1998 to that in 2010?
Give a very brief answer. 0.35. What is the ratio of the Emissions(in percent) in Latin America(developing only) in 2007 to that in 2008?
Your answer should be very brief. 1.08. What is the ratio of the Emissions(in percent) in Azerbaijan in 2007 to that in 2008?
Your answer should be very brief. 1.75. What is the ratio of the Emissions(in percent) in Israel in 2007 to that in 2008?
Your response must be concise. 1.11. What is the ratio of the Emissions(in percent) in Malawi in 2007 to that in 2008?
Your answer should be very brief. 1.43. What is the ratio of the Emissions(in percent) of Latin America(developing only) in 2007 to that in 2009?
Offer a very short reply. 1.18. What is the ratio of the Emissions(in percent) of Azerbaijan in 2007 to that in 2009?
Your response must be concise. 1.57. What is the ratio of the Emissions(in percent) of Israel in 2007 to that in 2009?
Your answer should be compact. 1.15. What is the ratio of the Emissions(in percent) in Malawi in 2007 to that in 2009?
Offer a very short reply. 1.39. What is the ratio of the Emissions(in percent) in Latin America(developing only) in 2007 to that in 2010?
Keep it short and to the point. 1.02. What is the ratio of the Emissions(in percent) in Israel in 2007 to that in 2010?
Your response must be concise. 1.18. What is the ratio of the Emissions(in percent) of Malawi in 2007 to that in 2010?
Ensure brevity in your answer.  1.47. What is the ratio of the Emissions(in percent) of Latin America(developing only) in 2008 to that in 2009?
Give a very brief answer. 1.09. What is the ratio of the Emissions(in percent) of Azerbaijan in 2008 to that in 2009?
Offer a very short reply. 0.9. What is the ratio of the Emissions(in percent) in Israel in 2008 to that in 2009?
Provide a short and direct response. 1.03. What is the ratio of the Emissions(in percent) in Malawi in 2008 to that in 2009?
Give a very brief answer. 0.97. What is the ratio of the Emissions(in percent) in Latin America(developing only) in 2008 to that in 2010?
Provide a succinct answer. 0.95. What is the ratio of the Emissions(in percent) of Azerbaijan in 2008 to that in 2010?
Provide a succinct answer. 0.58. What is the ratio of the Emissions(in percent) in Israel in 2008 to that in 2010?
Ensure brevity in your answer.  1.06. What is the ratio of the Emissions(in percent) of Malawi in 2008 to that in 2010?
Keep it short and to the point. 1.03. What is the ratio of the Emissions(in percent) in Latin America(developing only) in 2009 to that in 2010?
Ensure brevity in your answer.  0.87. What is the ratio of the Emissions(in percent) in Azerbaijan in 2009 to that in 2010?
Your answer should be compact. 0.64. What is the ratio of the Emissions(in percent) in Israel in 2009 to that in 2010?
Ensure brevity in your answer.  1.03. What is the ratio of the Emissions(in percent) of Malawi in 2009 to that in 2010?
Your answer should be compact. 1.06. What is the difference between the highest and the second highest Emissions(in percent) in Latin America(developing only)?
Provide a succinct answer. 0.05. What is the difference between the highest and the second highest Emissions(in percent) in Israel?
Offer a terse response. 4.46. What is the difference between the highest and the second highest Emissions(in percent) in Malawi?
Provide a succinct answer. 4.77. What is the difference between the highest and the lowest Emissions(in percent) of Latin America(developing only)?
Ensure brevity in your answer.  1.75. What is the difference between the highest and the lowest Emissions(in percent) of Azerbaijan?
Give a very brief answer. 0.06. What is the difference between the highest and the lowest Emissions(in percent) of Israel?
Your answer should be very brief. 13.44. What is the difference between the highest and the lowest Emissions(in percent) of Malawi?
Ensure brevity in your answer.  12.94. 